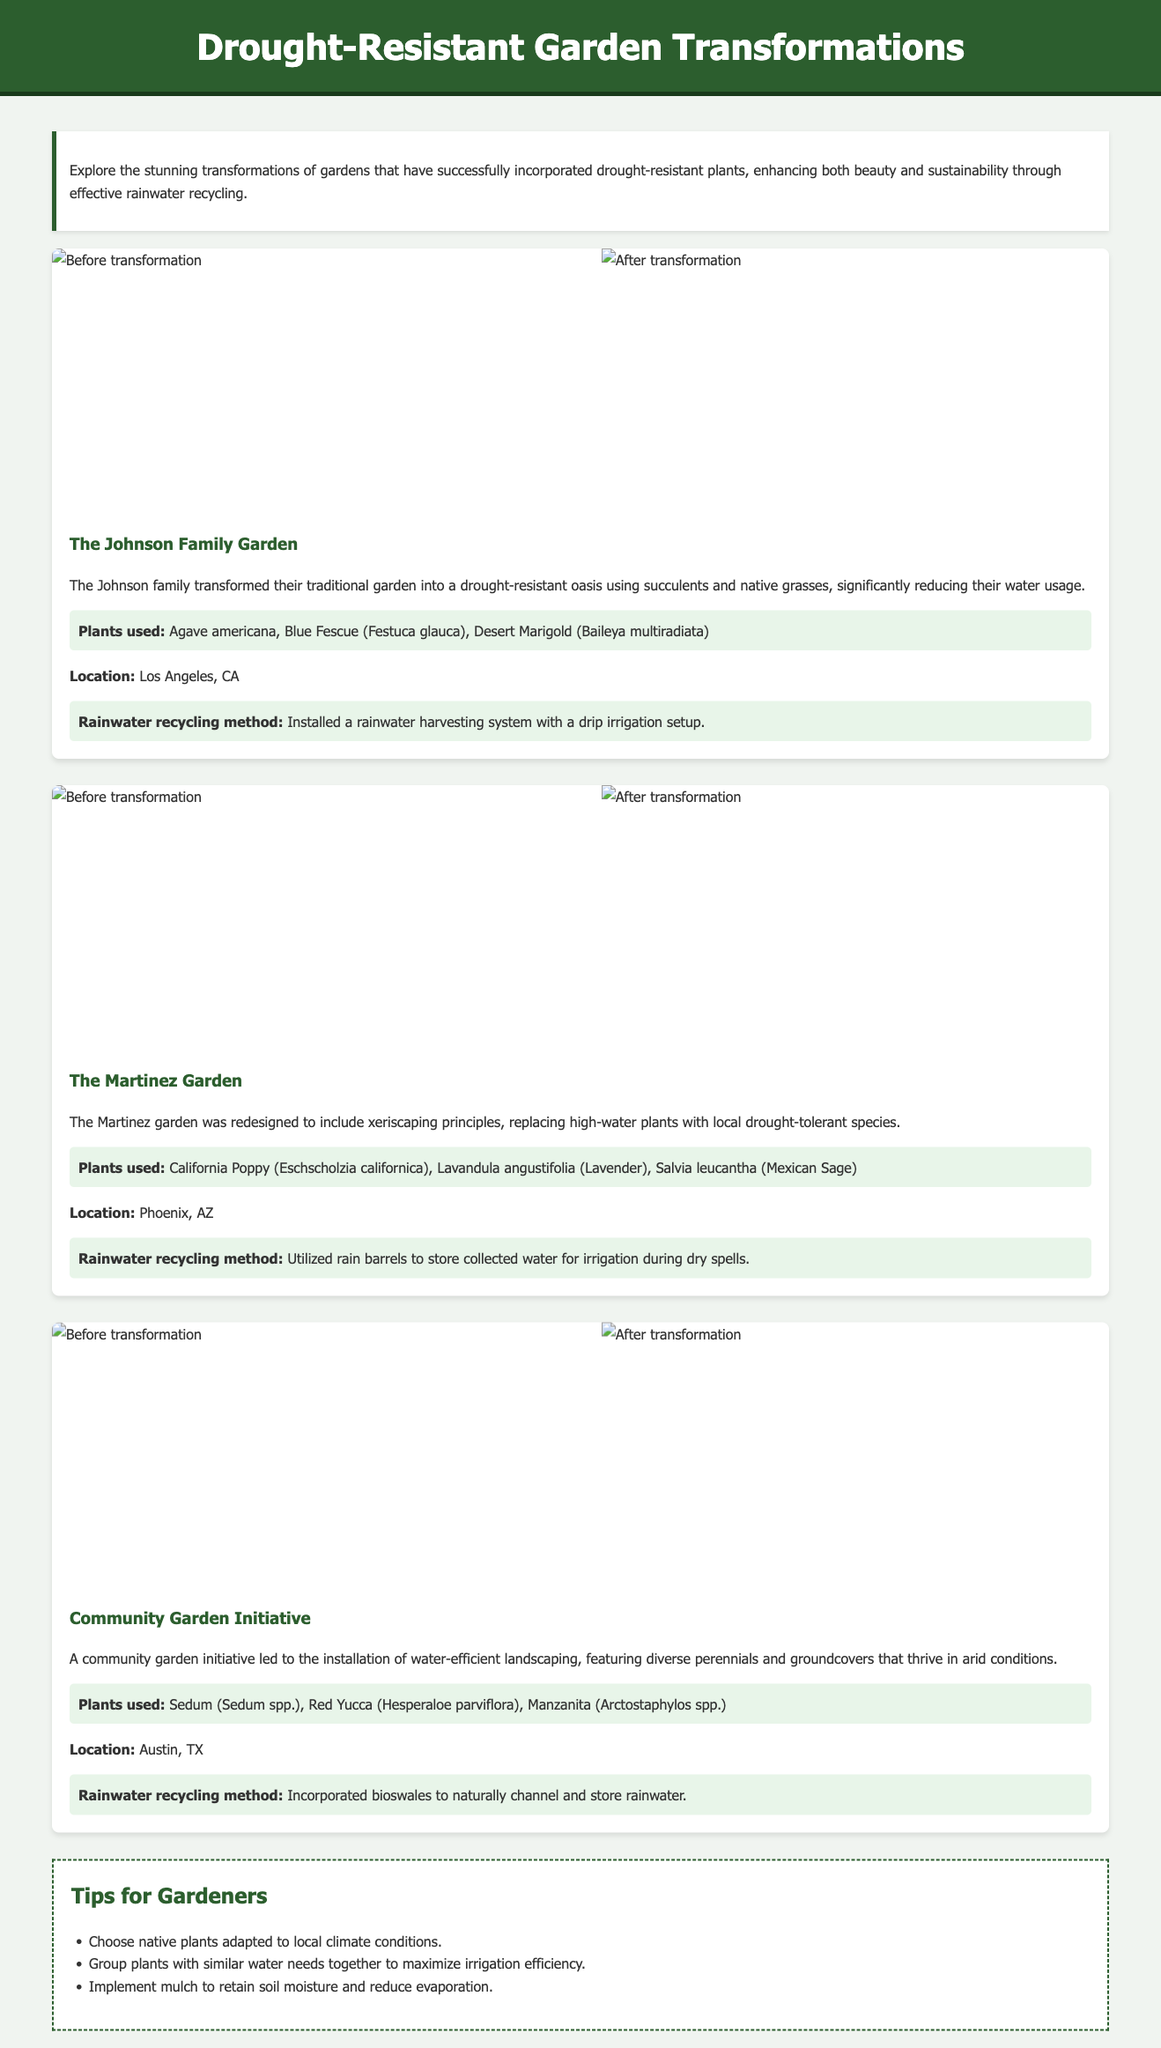What is the name of the first garden transformation featured? The document explicitly names the first transformation as "The Johnson Family Garden."
Answer: The Johnson Family Garden How many different gardens are showcased in the document? There are three distinct garden transformations presented in the document.
Answer: 3 What type of irrigation system was installed in the Johnson Family Garden? The document describes that a "rainwater harvesting system with a drip irrigation setup" was installed.
Answer: Drip irrigation system Which state is the Martinez Garden located in? The document states that the Martinez Garden is located in "Phoenix, AZ."
Answer: Phoenix, AZ What was used to store collected water in the Martinez Garden? The document indicates that "rain barrels" were utilized for water storage in the Martinez Garden.
Answer: Rain barrels What principle was followed in redesigning the Martinez Garden? The document mentions that the garden was redesigned to include "xeriscaping principles."
Answer: Xeriscaping principles What type of plants were highlighted in the Community Garden Initiative? The document lists "diverse perennials and groundcovers" that thrive in arid conditions.
Answer: Diverse perennials and groundcovers What recycling method was utilized in the Community Garden Initiative? According to the document, they "incorporated bioswales to naturally channel and store rainwater."
Answer: Bioswales What is one tip given for gardeners in the document? The document provides various tips, one of which is to "choose native plants adapted to local climate conditions."
Answer: Choose native plants 